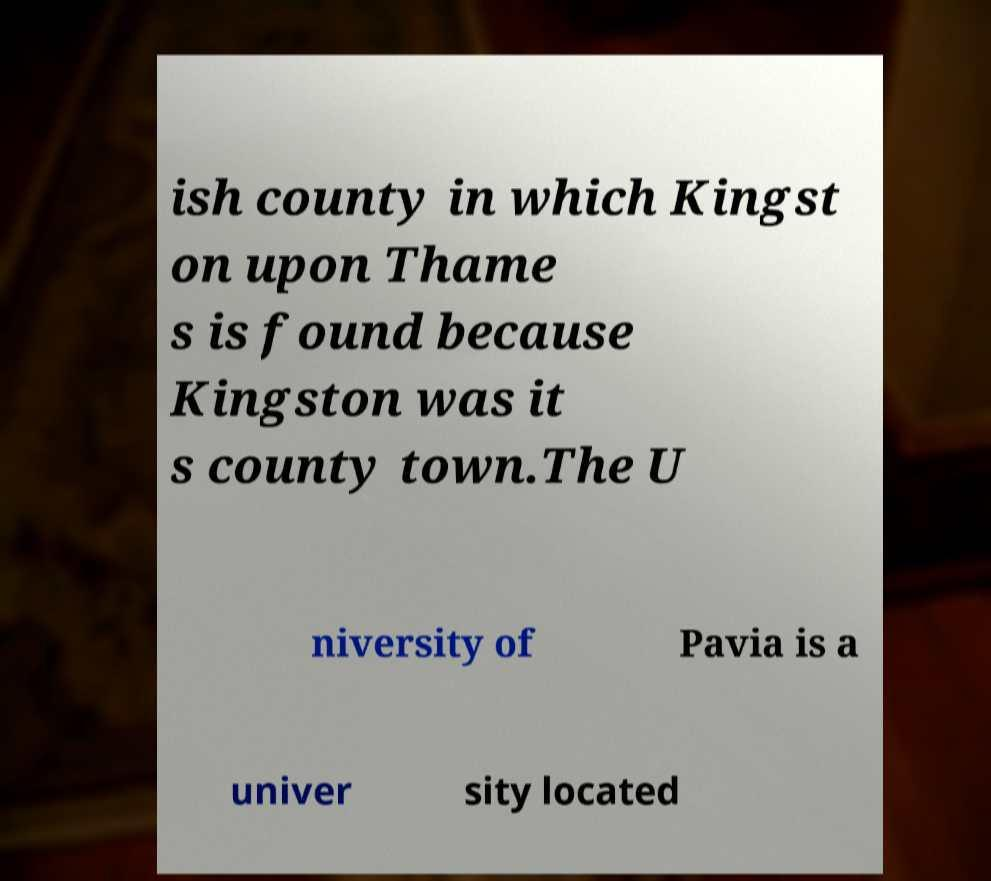There's text embedded in this image that I need extracted. Can you transcribe it verbatim? ish county in which Kingst on upon Thame s is found because Kingston was it s county town.The U niversity of Pavia is a univer sity located 